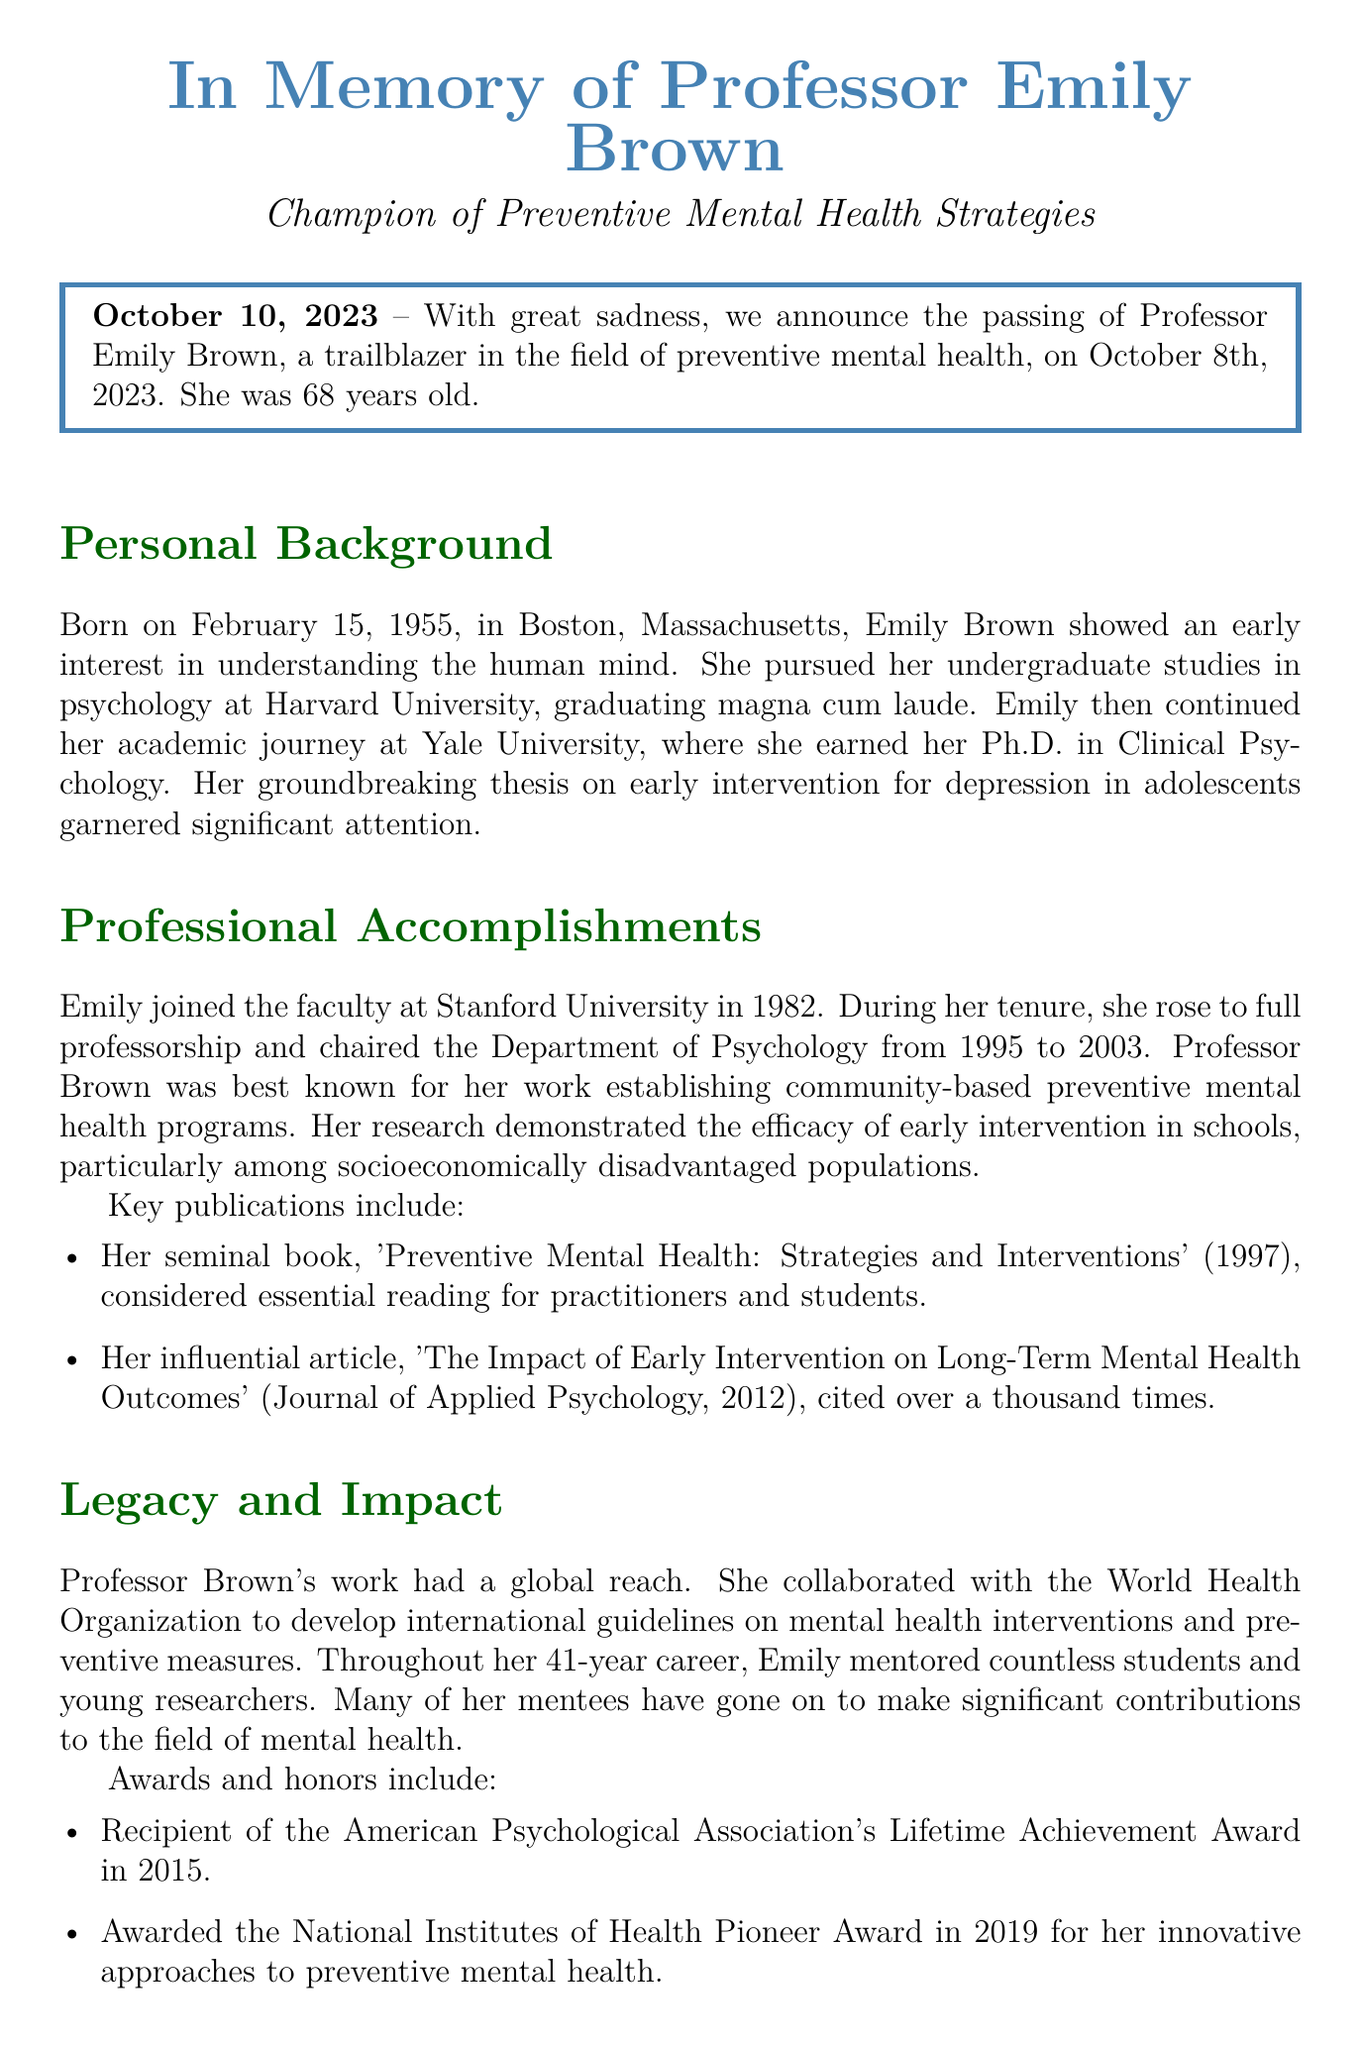What was the date of Professor Emily Brown's passing? The document states that she passed away on October 8th, 2023.
Answer: October 8th, 2023 How old was Professor Emily Brown when she passed away? The document indicates that she was 68 years old at the time of her passing.
Answer: 68 years old Where did Professor Brown earn her Ph.D.? The document mentions that she earned her Ph.D. at Yale University.
Answer: Yale University What was the title of Professor Brown's seminal book? The document states that her seminal book is titled 'Preventive Mental Health: Strategies and Interventions'.
Answer: Preventive Mental Health: Strategies and Interventions Which award did Professor Brown receive in 2015? The document notes that she received the American Psychological Association's Lifetime Achievement Award in 2015.
Answer: Lifetime Achievement Award What type of programs did Professor Brown establish? The document specifies that she established community-based preventive mental health programs.
Answer: Community-based preventive mental health programs How long was Professor Brown's career in academia? According to the document, she had a career in academia that spanned 41 years.
Answer: 41 years What was one of Emily's personal hobbies mentioned in the document? The document indicates that she enjoyed painting as one of her personal hobbies.
Answer: Painting Who survives Professor Brown? The document lists her husband Dr. Robert Brown, two daughters, and three grandchildren as her survivors.
Answer: Dr. Robert Brown, two daughters, and three grandchildren 